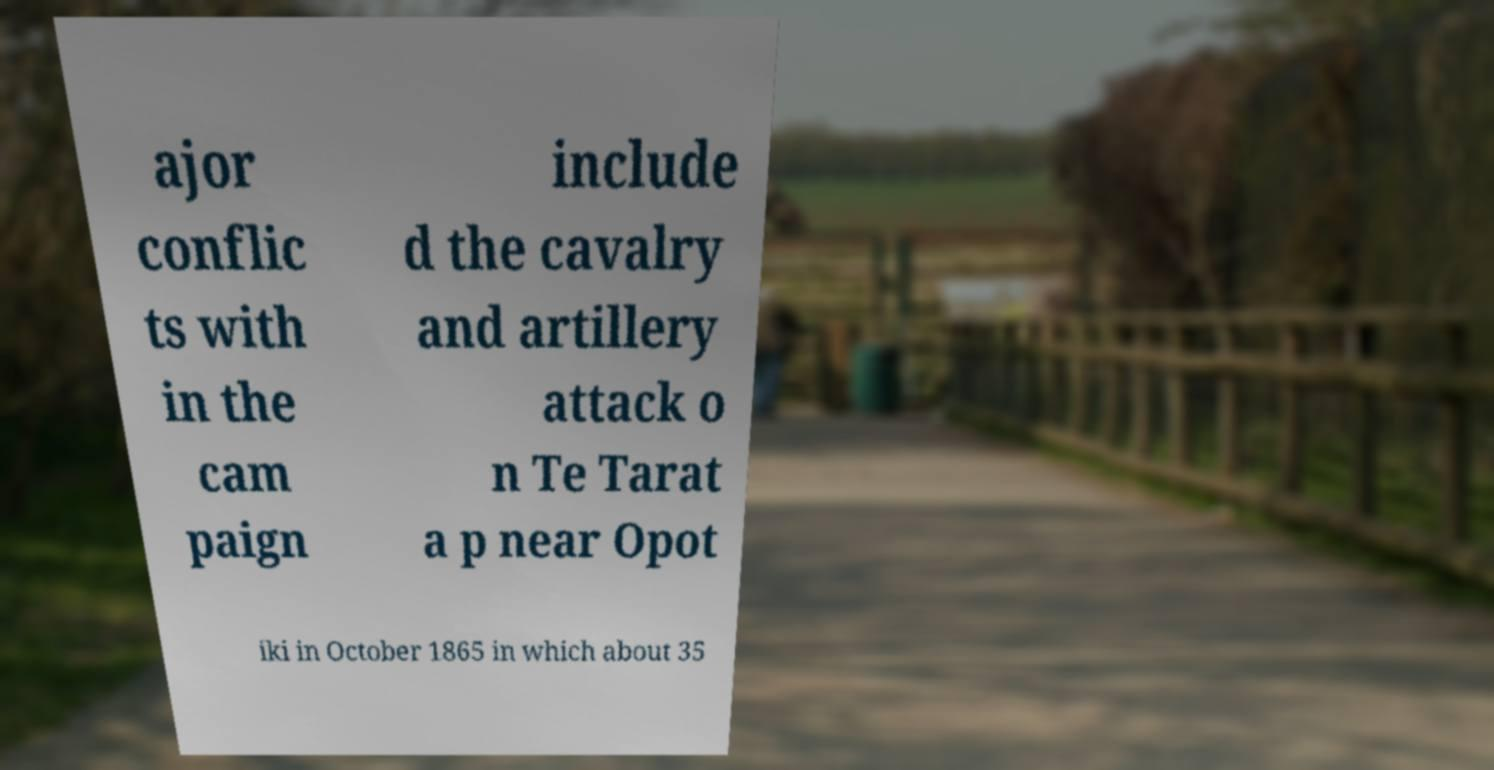Could you assist in decoding the text presented in this image and type it out clearly? ajor conflic ts with in the cam paign include d the cavalry and artillery attack o n Te Tarat a p near Opot iki in October 1865 in which about 35 